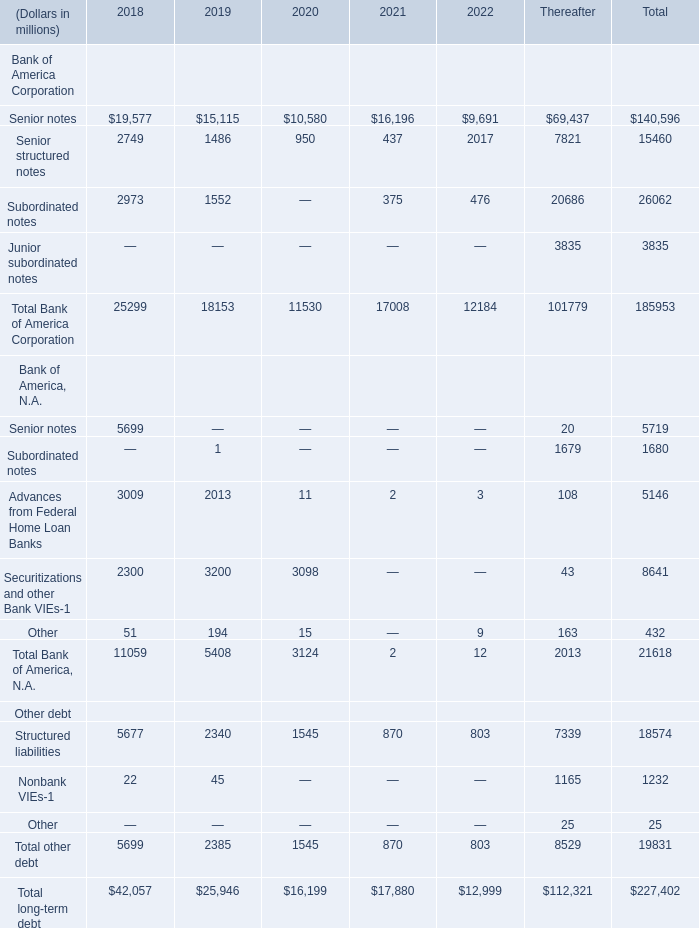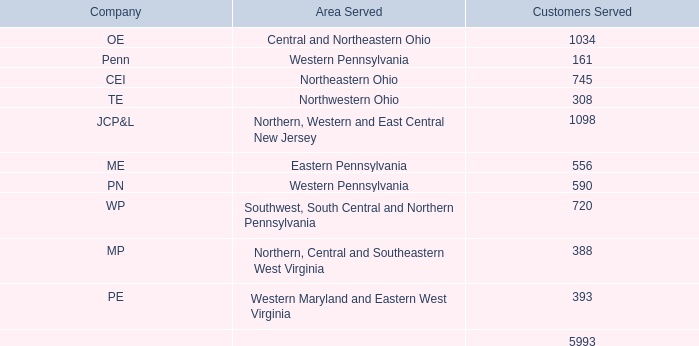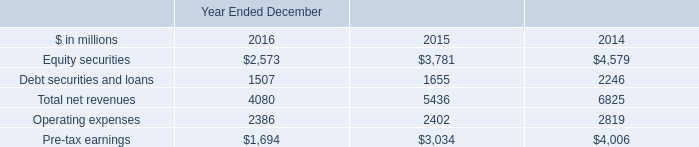What is the sum of Equity securities of Year Ended December 2015, and Nonbank VIEs Other debt of Thereafter ? 
Computations: (3781.0 + 1165.0)
Answer: 4946.0. 